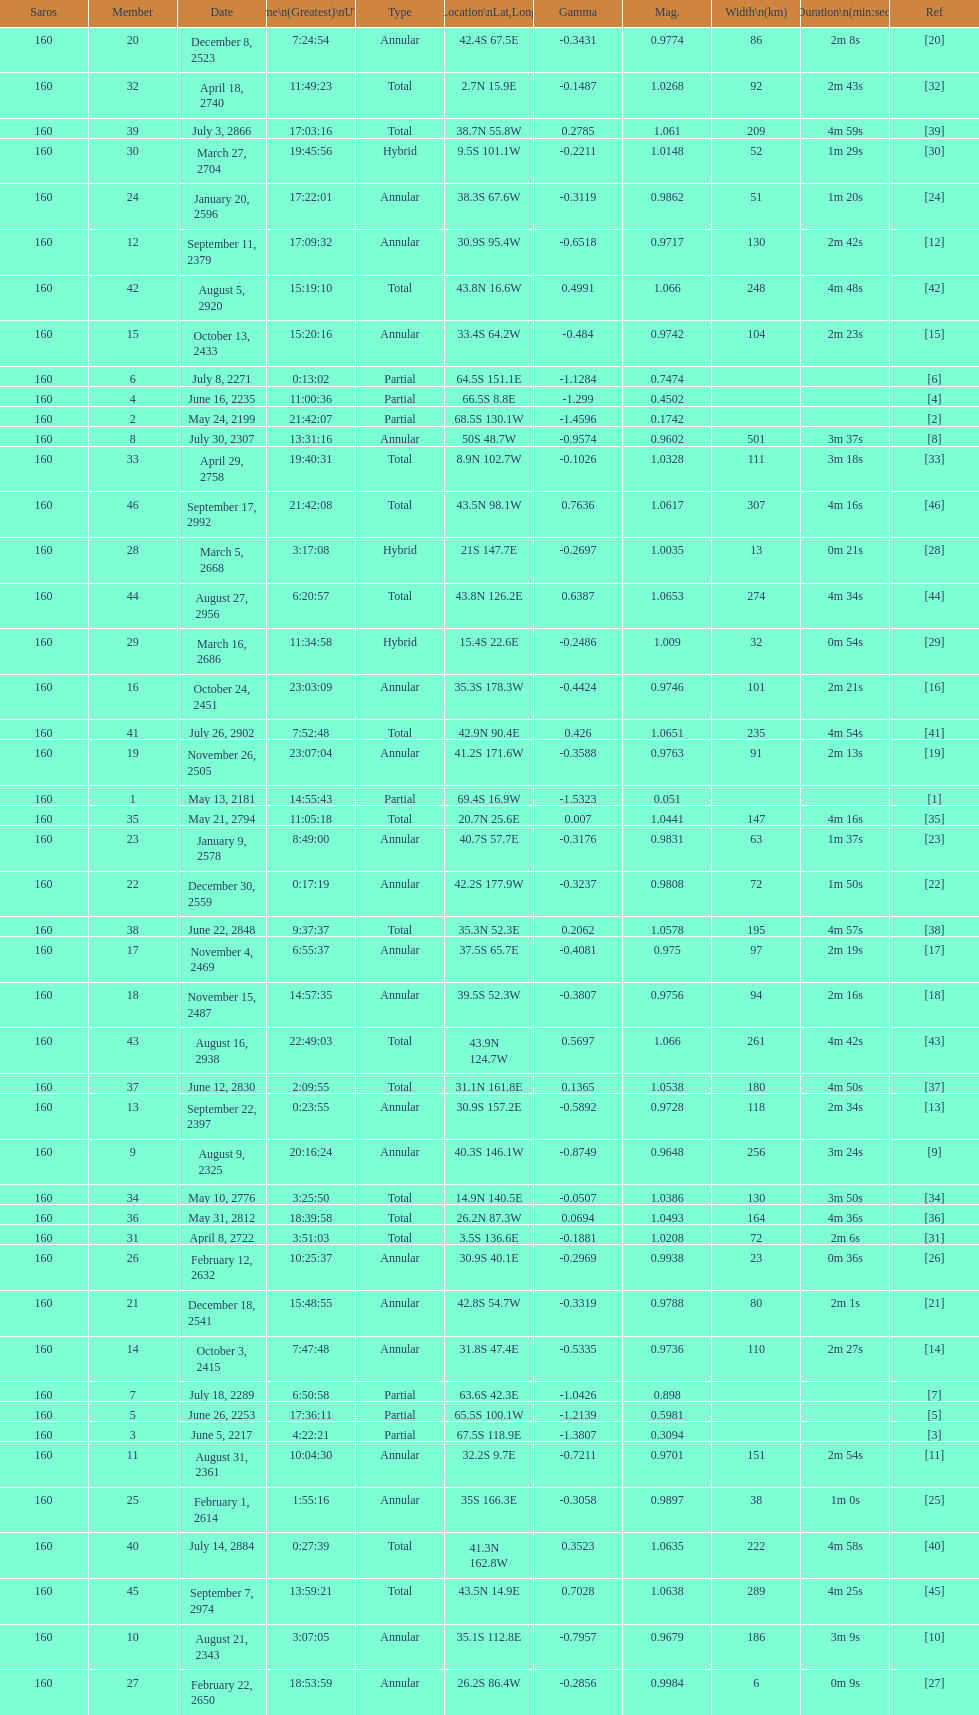When will the next solar saros be after the may 24, 2199 solar saros occurs? June 5, 2217. Give me the full table as a dictionary. {'header': ['Saros', 'Member', 'Date', 'Time\\n(Greatest)\\nUTC', 'Type', 'Location\\nLat,Long', 'Gamma', 'Mag.', 'Width\\n(km)', 'Duration\\n(min:sec)', 'Ref'], 'rows': [['160', '20', 'December 8, 2523', '7:24:54', 'Annular', '42.4S 67.5E', '-0.3431', '0.9774', '86', '2m 8s', '[20]'], ['160', '32', 'April 18, 2740', '11:49:23', 'Total', '2.7N 15.9E', '-0.1487', '1.0268', '92', '2m 43s', '[32]'], ['160', '39', 'July 3, 2866', '17:03:16', 'Total', '38.7N 55.8W', '0.2785', '1.061', '209', '4m 59s', '[39]'], ['160', '30', 'March 27, 2704', '19:45:56', 'Hybrid', '9.5S 101.1W', '-0.2211', '1.0148', '52', '1m 29s', '[30]'], ['160', '24', 'January 20, 2596', '17:22:01', 'Annular', '38.3S 67.6W', '-0.3119', '0.9862', '51', '1m 20s', '[24]'], ['160', '12', 'September 11, 2379', '17:09:32', 'Annular', '30.9S 95.4W', '-0.6518', '0.9717', '130', '2m 42s', '[12]'], ['160', '42', 'August 5, 2920', '15:19:10', 'Total', '43.8N 16.6W', '0.4991', '1.066', '248', '4m 48s', '[42]'], ['160', '15', 'October 13, 2433', '15:20:16', 'Annular', '33.4S 64.2W', '-0.484', '0.9742', '104', '2m 23s', '[15]'], ['160', '6', 'July 8, 2271', '0:13:02', 'Partial', '64.5S 151.1E', '-1.1284', '0.7474', '', '', '[6]'], ['160', '4', 'June 16, 2235', '11:00:36', 'Partial', '66.5S 8.8E', '-1.299', '0.4502', '', '', '[4]'], ['160', '2', 'May 24, 2199', '21:42:07', 'Partial', '68.5S 130.1W', '-1.4596', '0.1742', '', '', '[2]'], ['160', '8', 'July 30, 2307', '13:31:16', 'Annular', '50S 48.7W', '-0.9574', '0.9602', '501', '3m 37s', '[8]'], ['160', '33', 'April 29, 2758', '19:40:31', 'Total', '8.9N 102.7W', '-0.1026', '1.0328', '111', '3m 18s', '[33]'], ['160', '46', 'September 17, 2992', '21:42:08', 'Total', '43.5N 98.1W', '0.7636', '1.0617', '307', '4m 16s', '[46]'], ['160', '28', 'March 5, 2668', '3:17:08', 'Hybrid', '21S 147.7E', '-0.2697', '1.0035', '13', '0m 21s', '[28]'], ['160', '44', 'August 27, 2956', '6:20:57', 'Total', '43.8N 126.2E', '0.6387', '1.0653', '274', '4m 34s', '[44]'], ['160', '29', 'March 16, 2686', '11:34:58', 'Hybrid', '15.4S 22.6E', '-0.2486', '1.009', '32', '0m 54s', '[29]'], ['160', '16', 'October 24, 2451', '23:03:09', 'Annular', '35.3S 178.3W', '-0.4424', '0.9746', '101', '2m 21s', '[16]'], ['160', '41', 'July 26, 2902', '7:52:48', 'Total', '42.9N 90.4E', '0.426', '1.0651', '235', '4m 54s', '[41]'], ['160', '19', 'November 26, 2505', '23:07:04', 'Annular', '41.2S 171.6W', '-0.3588', '0.9763', '91', '2m 13s', '[19]'], ['160', '1', 'May 13, 2181', '14:55:43', 'Partial', '69.4S 16.9W', '-1.5323', '0.051', '', '', '[1]'], ['160', '35', 'May 21, 2794', '11:05:18', 'Total', '20.7N 25.6E', '0.007', '1.0441', '147', '4m 16s', '[35]'], ['160', '23', 'January 9, 2578', '8:49:00', 'Annular', '40.7S 57.7E', '-0.3176', '0.9831', '63', '1m 37s', '[23]'], ['160', '22', 'December 30, 2559', '0:17:19', 'Annular', '42.2S 177.9W', '-0.3237', '0.9808', '72', '1m 50s', '[22]'], ['160', '38', 'June 22, 2848', '9:37:37', 'Total', '35.3N 52.3E', '0.2062', '1.0578', '195', '4m 57s', '[38]'], ['160', '17', 'November 4, 2469', '6:55:37', 'Annular', '37.5S 65.7E', '-0.4081', '0.975', '97', '2m 19s', '[17]'], ['160', '18', 'November 15, 2487', '14:57:35', 'Annular', '39.5S 52.3W', '-0.3807', '0.9756', '94', '2m 16s', '[18]'], ['160', '43', 'August 16, 2938', '22:49:03', 'Total', '43.9N 124.7W', '0.5697', '1.066', '261', '4m 42s', '[43]'], ['160', '37', 'June 12, 2830', '2:09:55', 'Total', '31.1N 161.8E', '0.1365', '1.0538', '180', '4m 50s', '[37]'], ['160', '13', 'September 22, 2397', '0:23:55', 'Annular', '30.9S 157.2E', '-0.5892', '0.9728', '118', '2m 34s', '[13]'], ['160', '9', 'August 9, 2325', '20:16:24', 'Annular', '40.3S 146.1W', '-0.8749', '0.9648', '256', '3m 24s', '[9]'], ['160', '34', 'May 10, 2776', '3:25:50', 'Total', '14.9N 140.5E', '-0.0507', '1.0386', '130', '3m 50s', '[34]'], ['160', '36', 'May 31, 2812', '18:39:58', 'Total', '26.2N 87.3W', '0.0694', '1.0493', '164', '4m 36s', '[36]'], ['160', '31', 'April 8, 2722', '3:51:03', 'Total', '3.5S 136.6E', '-0.1881', '1.0208', '72', '2m 6s', '[31]'], ['160', '26', 'February 12, 2632', '10:25:37', 'Annular', '30.9S 40.1E', '-0.2969', '0.9938', '23', '0m 36s', '[26]'], ['160', '21', 'December 18, 2541', '15:48:55', 'Annular', '42.8S 54.7W', '-0.3319', '0.9788', '80', '2m 1s', '[21]'], ['160', '14', 'October 3, 2415', '7:47:48', 'Annular', '31.8S 47.4E', '-0.5335', '0.9736', '110', '2m 27s', '[14]'], ['160', '7', 'July 18, 2289', '6:50:58', 'Partial', '63.6S 42.3E', '-1.0426', '0.898', '', '', '[7]'], ['160', '5', 'June 26, 2253', '17:36:11', 'Partial', '65.5S 100.1W', '-1.2139', '0.5981', '', '', '[5]'], ['160', '3', 'June 5, 2217', '4:22:21', 'Partial', '67.5S 118.9E', '-1.3807', '0.3094', '', '', '[3]'], ['160', '11', 'August 31, 2361', '10:04:30', 'Annular', '32.2S 9.7E', '-0.7211', '0.9701', '151', '2m 54s', '[11]'], ['160', '25', 'February 1, 2614', '1:55:16', 'Annular', '35S 166.3E', '-0.3058', '0.9897', '38', '1m 0s', '[25]'], ['160', '40', 'July 14, 2884', '0:27:39', 'Total', '41.3N 162.8W', '0.3523', '1.0635', '222', '4m 58s', '[40]'], ['160', '45', 'September 7, 2974', '13:59:21', 'Total', '43.5N 14.9E', '0.7028', '1.0638', '289', '4m 25s', '[45]'], ['160', '10', 'August 21, 2343', '3:07:05', 'Annular', '35.1S 112.8E', '-0.7957', '0.9679', '186', '3m 9s', '[10]'], ['160', '27', 'February 22, 2650', '18:53:59', 'Annular', '26.2S 86.4W', '-0.2856', '0.9984', '6', '0m 9s', '[27]']]} 